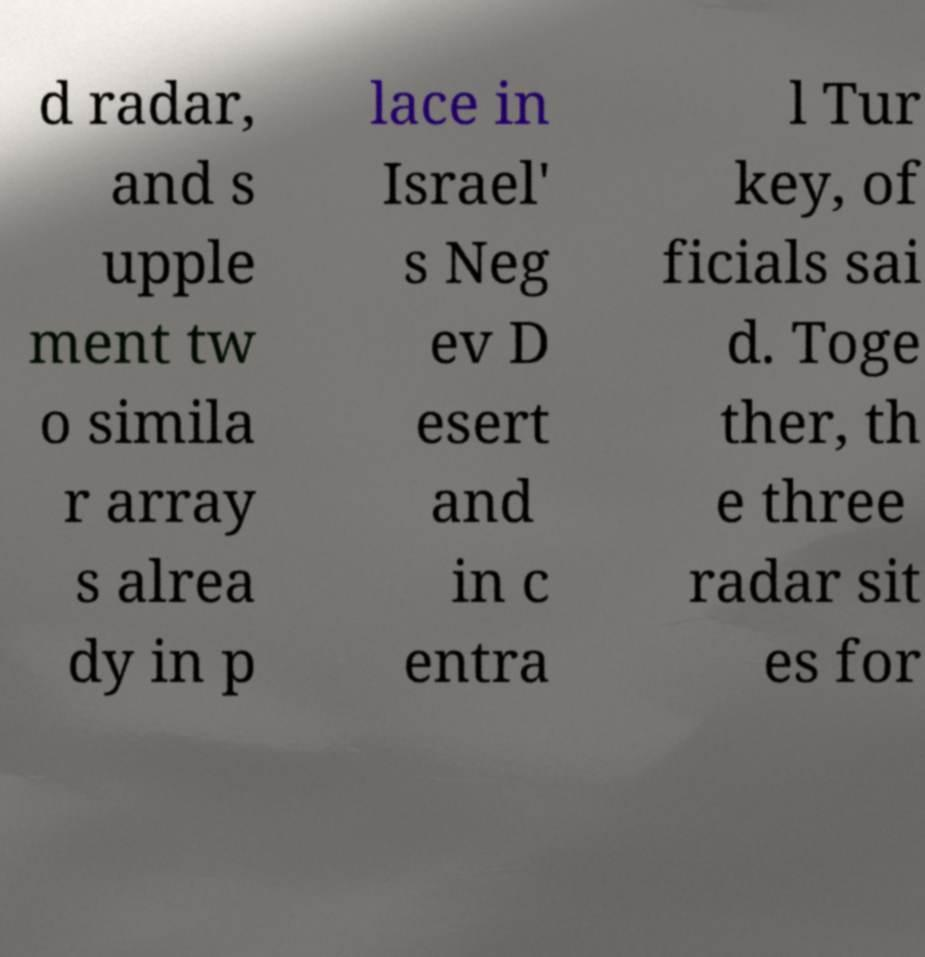Can you accurately transcribe the text from the provided image for me? d radar, and s upple ment tw o simila r array s alrea dy in p lace in Israel' s Neg ev D esert and in c entra l Tur key, of ficials sai d. Toge ther, th e three radar sit es for 